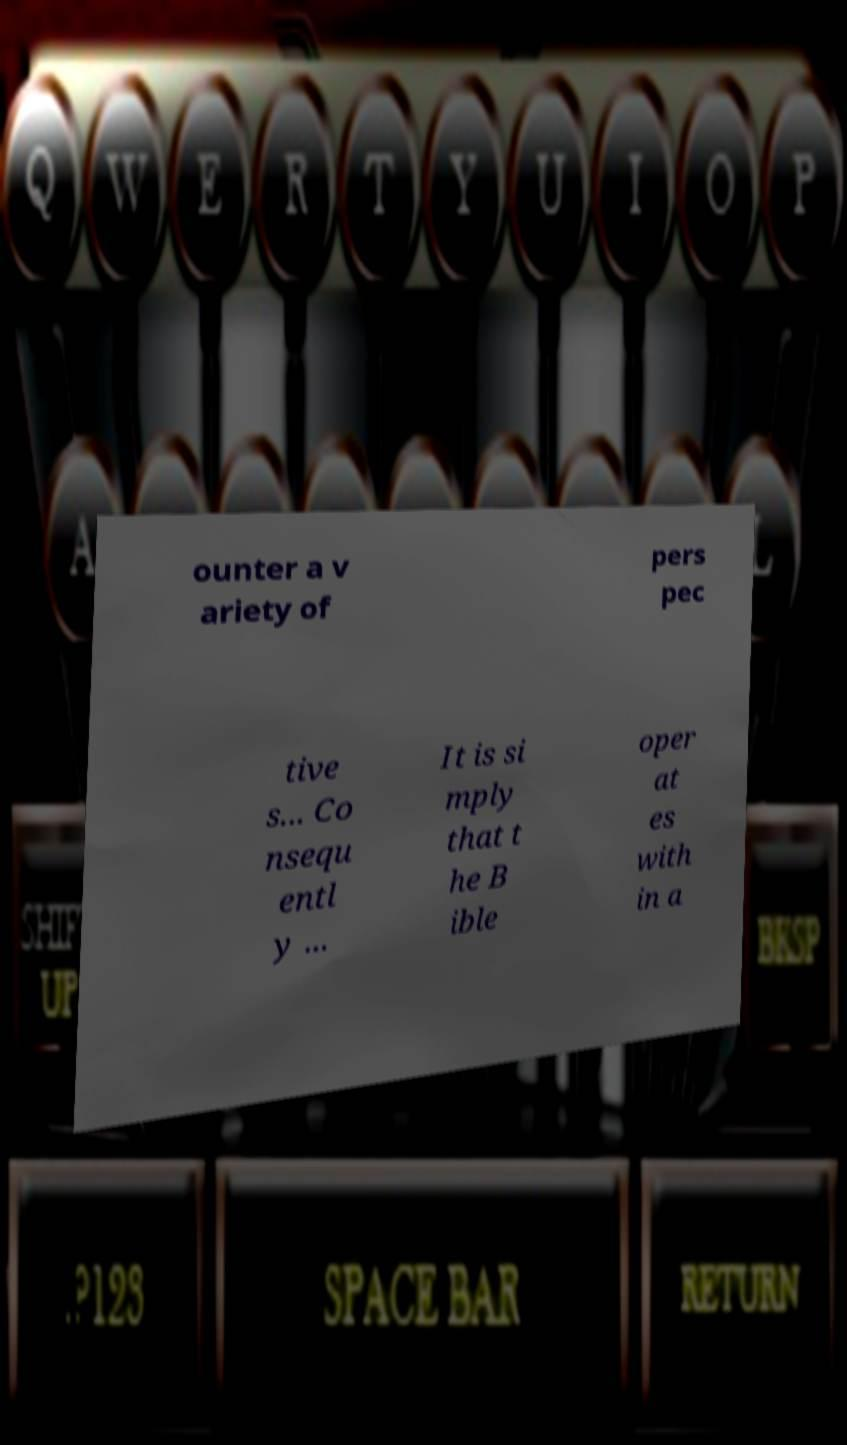Can you read and provide the text displayed in the image?This photo seems to have some interesting text. Can you extract and type it out for me? ounter a v ariety of pers pec tive s... Co nsequ entl y ... It is si mply that t he B ible oper at es with in a 